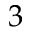Convert formula to latex. <formula><loc_0><loc_0><loc_500><loc_500>3</formula> 